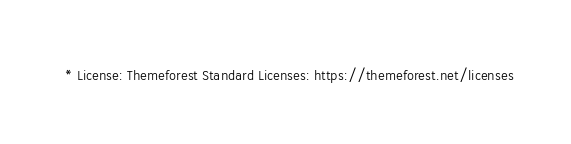<code> <loc_0><loc_0><loc_500><loc_500><_CSS_>  * License: Themeforest Standard Licenses: https://themeforest.net/licenses</code> 